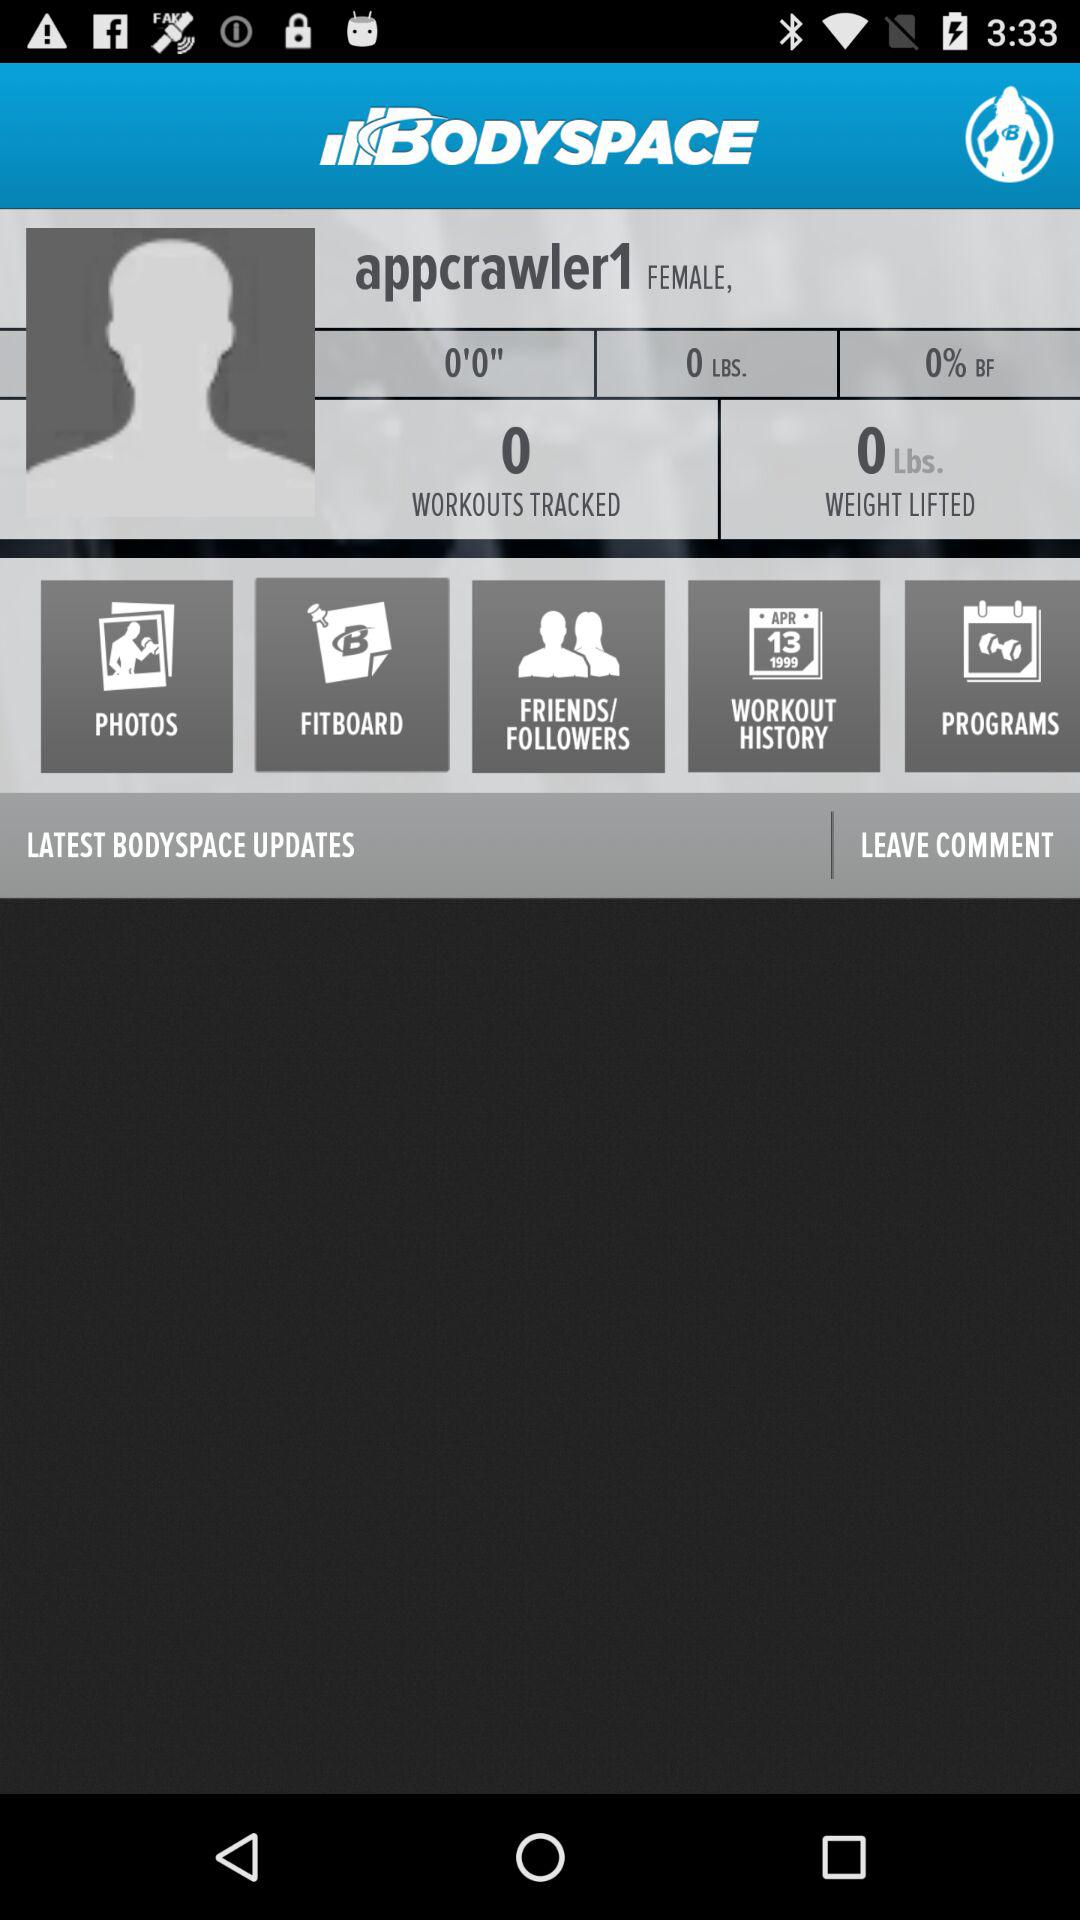How many workouts are tracked? There are 0 workouts tracked. 